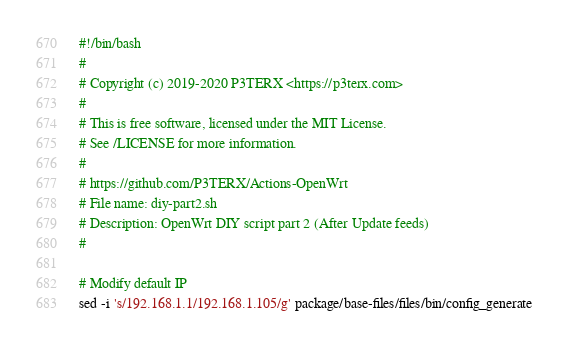<code> <loc_0><loc_0><loc_500><loc_500><_Bash_>#!/bin/bash
#
# Copyright (c) 2019-2020 P3TERX <https://p3terx.com>
#
# This is free software, licensed under the MIT License.
# See /LICENSE for more information.
#
# https://github.com/P3TERX/Actions-OpenWrt
# File name: diy-part2.sh
# Description: OpenWrt DIY script part 2 (After Update feeds)
#

# Modify default IP
sed -i 's/192.168.1.1/192.168.1.105/g' package/base-files/files/bin/config_generate
</code> 